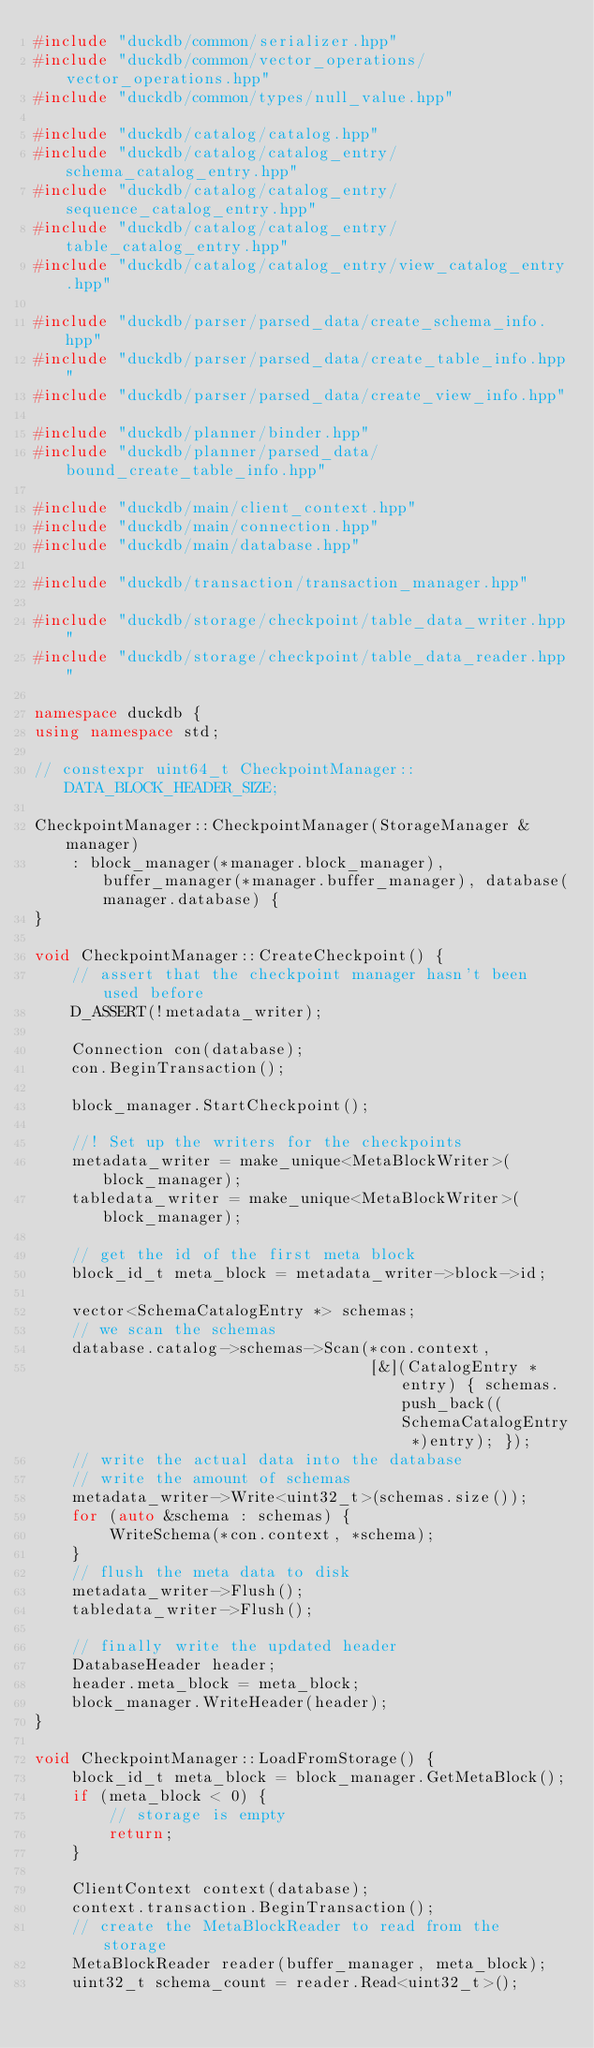<code> <loc_0><loc_0><loc_500><loc_500><_C++_>#include "duckdb/common/serializer.hpp"
#include "duckdb/common/vector_operations/vector_operations.hpp"
#include "duckdb/common/types/null_value.hpp"

#include "duckdb/catalog/catalog.hpp"
#include "duckdb/catalog/catalog_entry/schema_catalog_entry.hpp"
#include "duckdb/catalog/catalog_entry/sequence_catalog_entry.hpp"
#include "duckdb/catalog/catalog_entry/table_catalog_entry.hpp"
#include "duckdb/catalog/catalog_entry/view_catalog_entry.hpp"

#include "duckdb/parser/parsed_data/create_schema_info.hpp"
#include "duckdb/parser/parsed_data/create_table_info.hpp"
#include "duckdb/parser/parsed_data/create_view_info.hpp"

#include "duckdb/planner/binder.hpp"
#include "duckdb/planner/parsed_data/bound_create_table_info.hpp"

#include "duckdb/main/client_context.hpp"
#include "duckdb/main/connection.hpp"
#include "duckdb/main/database.hpp"

#include "duckdb/transaction/transaction_manager.hpp"

#include "duckdb/storage/checkpoint/table_data_writer.hpp"
#include "duckdb/storage/checkpoint/table_data_reader.hpp"

namespace duckdb {
using namespace std;

// constexpr uint64_t CheckpointManager::DATA_BLOCK_HEADER_SIZE;

CheckpointManager::CheckpointManager(StorageManager &manager)
    : block_manager(*manager.block_manager), buffer_manager(*manager.buffer_manager), database(manager.database) {
}

void CheckpointManager::CreateCheckpoint() {
	// assert that the checkpoint manager hasn't been used before
	D_ASSERT(!metadata_writer);

	Connection con(database);
	con.BeginTransaction();

	block_manager.StartCheckpoint();

	//! Set up the writers for the checkpoints
	metadata_writer = make_unique<MetaBlockWriter>(block_manager);
	tabledata_writer = make_unique<MetaBlockWriter>(block_manager);

	// get the id of the first meta block
	block_id_t meta_block = metadata_writer->block->id;

	vector<SchemaCatalogEntry *> schemas;
	// we scan the schemas
	database.catalog->schemas->Scan(*con.context,
	                                [&](CatalogEntry *entry) { schemas.push_back((SchemaCatalogEntry *)entry); });
	// write the actual data into the database
	// write the amount of schemas
	metadata_writer->Write<uint32_t>(schemas.size());
	for (auto &schema : schemas) {
		WriteSchema(*con.context, *schema);
	}
	// flush the meta data to disk
	metadata_writer->Flush();
	tabledata_writer->Flush();

	// finally write the updated header
	DatabaseHeader header;
	header.meta_block = meta_block;
	block_manager.WriteHeader(header);
}

void CheckpointManager::LoadFromStorage() {
	block_id_t meta_block = block_manager.GetMetaBlock();
	if (meta_block < 0) {
		// storage is empty
		return;
	}

	ClientContext context(database);
	context.transaction.BeginTransaction();
	// create the MetaBlockReader to read from the storage
	MetaBlockReader reader(buffer_manager, meta_block);
	uint32_t schema_count = reader.Read<uint32_t>();</code> 